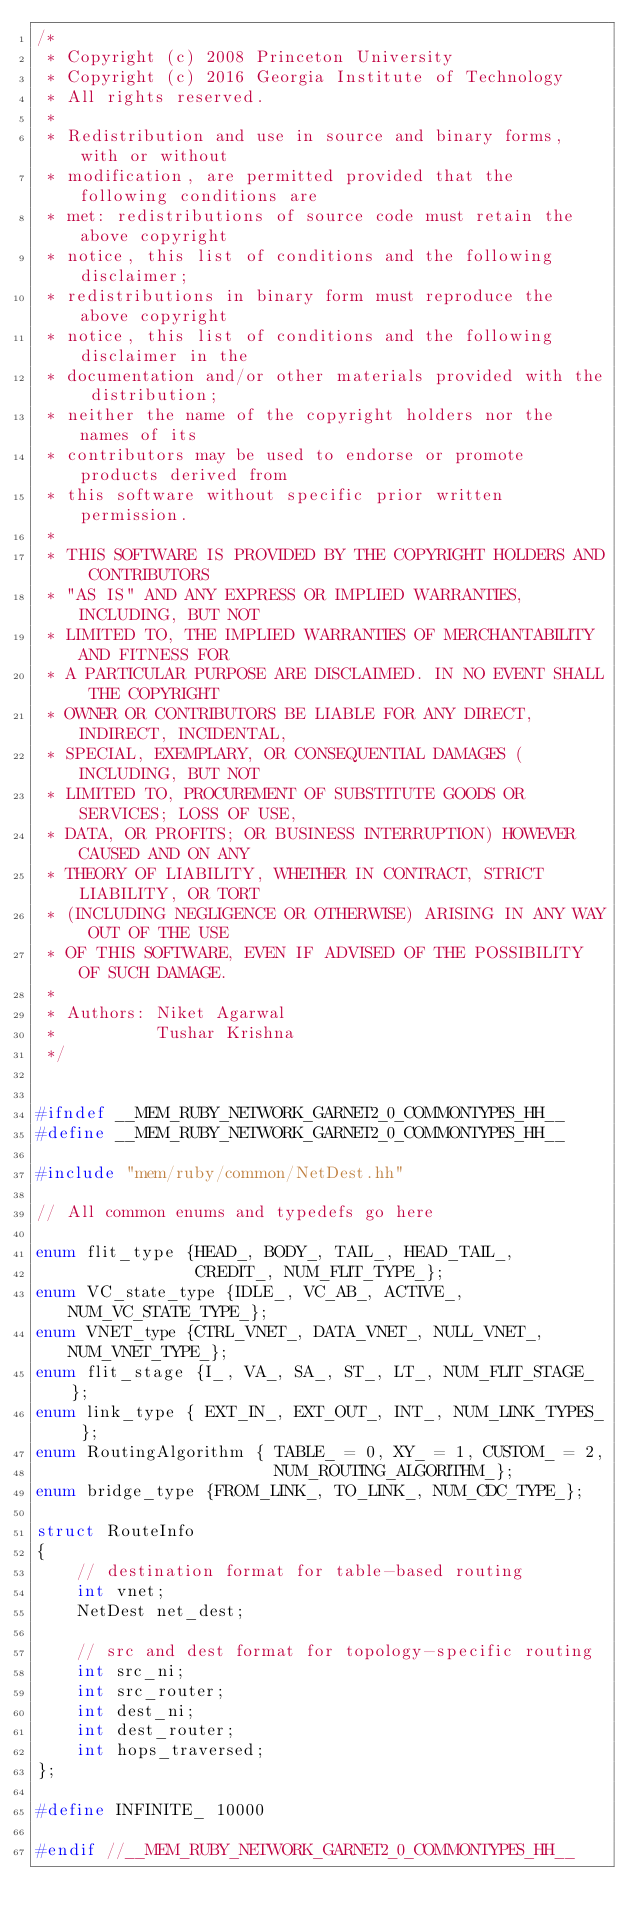Convert code to text. <code><loc_0><loc_0><loc_500><loc_500><_C++_>/*
 * Copyright (c) 2008 Princeton University
 * Copyright (c) 2016 Georgia Institute of Technology
 * All rights reserved.
 *
 * Redistribution and use in source and binary forms, with or without
 * modification, are permitted provided that the following conditions are
 * met: redistributions of source code must retain the above copyright
 * notice, this list of conditions and the following disclaimer;
 * redistributions in binary form must reproduce the above copyright
 * notice, this list of conditions and the following disclaimer in the
 * documentation and/or other materials provided with the distribution;
 * neither the name of the copyright holders nor the names of its
 * contributors may be used to endorse or promote products derived from
 * this software without specific prior written permission.
 *
 * THIS SOFTWARE IS PROVIDED BY THE COPYRIGHT HOLDERS AND CONTRIBUTORS
 * "AS IS" AND ANY EXPRESS OR IMPLIED WARRANTIES, INCLUDING, BUT NOT
 * LIMITED TO, THE IMPLIED WARRANTIES OF MERCHANTABILITY AND FITNESS FOR
 * A PARTICULAR PURPOSE ARE DISCLAIMED. IN NO EVENT SHALL THE COPYRIGHT
 * OWNER OR CONTRIBUTORS BE LIABLE FOR ANY DIRECT, INDIRECT, INCIDENTAL,
 * SPECIAL, EXEMPLARY, OR CONSEQUENTIAL DAMAGES (INCLUDING, BUT NOT
 * LIMITED TO, PROCUREMENT OF SUBSTITUTE GOODS OR SERVICES; LOSS OF USE,
 * DATA, OR PROFITS; OR BUSINESS INTERRUPTION) HOWEVER CAUSED AND ON ANY
 * THEORY OF LIABILITY, WHETHER IN CONTRACT, STRICT LIABILITY, OR TORT
 * (INCLUDING NEGLIGENCE OR OTHERWISE) ARISING IN ANY WAY OUT OF THE USE
 * OF THIS SOFTWARE, EVEN IF ADVISED OF THE POSSIBILITY OF SUCH DAMAGE.
 *
 * Authors: Niket Agarwal
 *          Tushar Krishna
 */


#ifndef __MEM_RUBY_NETWORK_GARNET2_0_COMMONTYPES_HH__
#define __MEM_RUBY_NETWORK_GARNET2_0_COMMONTYPES_HH__

#include "mem/ruby/common/NetDest.hh"

// All common enums and typedefs go here

enum flit_type {HEAD_, BODY_, TAIL_, HEAD_TAIL_,
                CREDIT_, NUM_FLIT_TYPE_};
enum VC_state_type {IDLE_, VC_AB_, ACTIVE_, NUM_VC_STATE_TYPE_};
enum VNET_type {CTRL_VNET_, DATA_VNET_, NULL_VNET_, NUM_VNET_TYPE_};
enum flit_stage {I_, VA_, SA_, ST_, LT_, NUM_FLIT_STAGE_};
enum link_type { EXT_IN_, EXT_OUT_, INT_, NUM_LINK_TYPES_ };
enum RoutingAlgorithm { TABLE_ = 0, XY_ = 1, CUSTOM_ = 2,
                        NUM_ROUTING_ALGORITHM_};
enum bridge_type {FROM_LINK_, TO_LINK_, NUM_CDC_TYPE_};

struct RouteInfo
{
    // destination format for table-based routing
    int vnet;
    NetDest net_dest;

    // src and dest format for topology-specific routing
    int src_ni;
    int src_router;
    int dest_ni;
    int dest_router;
    int hops_traversed;
};

#define INFINITE_ 10000

#endif //__MEM_RUBY_NETWORK_GARNET2_0_COMMONTYPES_HH__
</code> 